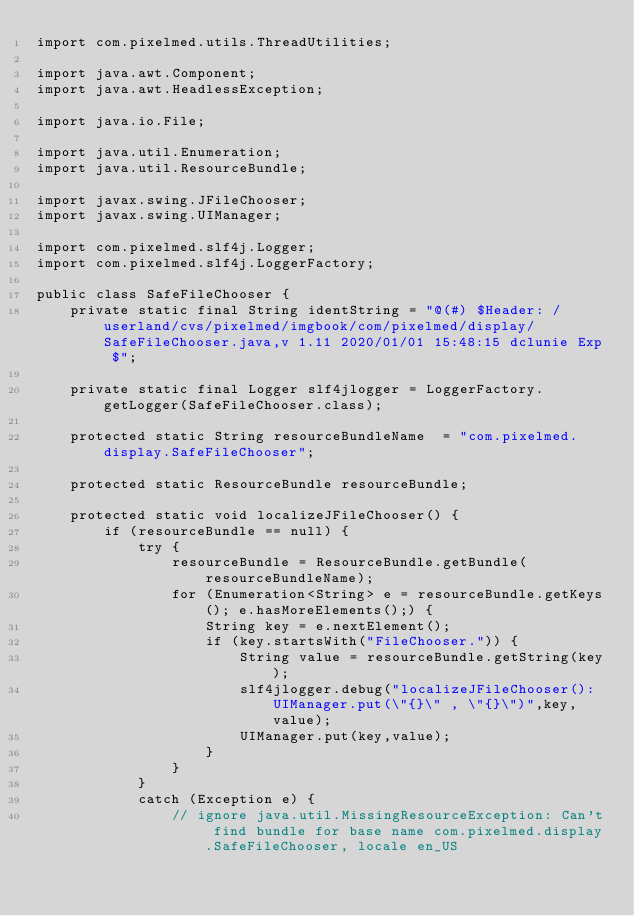<code> <loc_0><loc_0><loc_500><loc_500><_Java_>import com.pixelmed.utils.ThreadUtilities;

import java.awt.Component;
import java.awt.HeadlessException;

import java.io.File;

import java.util.Enumeration;
import java.util.ResourceBundle;

import javax.swing.JFileChooser;
import javax.swing.UIManager;

import com.pixelmed.slf4j.Logger;
import com.pixelmed.slf4j.LoggerFactory;

public class SafeFileChooser {
	private static final String identString = "@(#) $Header: /userland/cvs/pixelmed/imgbook/com/pixelmed/display/SafeFileChooser.java,v 1.11 2020/01/01 15:48:15 dclunie Exp $";

	private static final Logger slf4jlogger = LoggerFactory.getLogger(SafeFileChooser.class);

	protected static String resourceBundleName  = "com.pixelmed.display.SafeFileChooser";
	
	protected static ResourceBundle resourceBundle;
	
	protected static void localizeJFileChooser() {
		if (resourceBundle == null) {
			try {
				resourceBundle = ResourceBundle.getBundle(resourceBundleName);
				for (Enumeration<String> e = resourceBundle.getKeys(); e.hasMoreElements();) {
					String key = e.nextElement();
					if (key.startsWith("FileChooser.")) {
						String value = resourceBundle.getString(key);
						slf4jlogger.debug("localizeJFileChooser(): UIManager.put(\"{}\" , \"{}\")",key,value);
						UIManager.put(key,value);
					}
				}
			}
			catch (Exception e) {
				// ignore java.util.MissingResourceException: Can't find bundle for base name com.pixelmed.display.SafeFileChooser, locale en_US</code> 